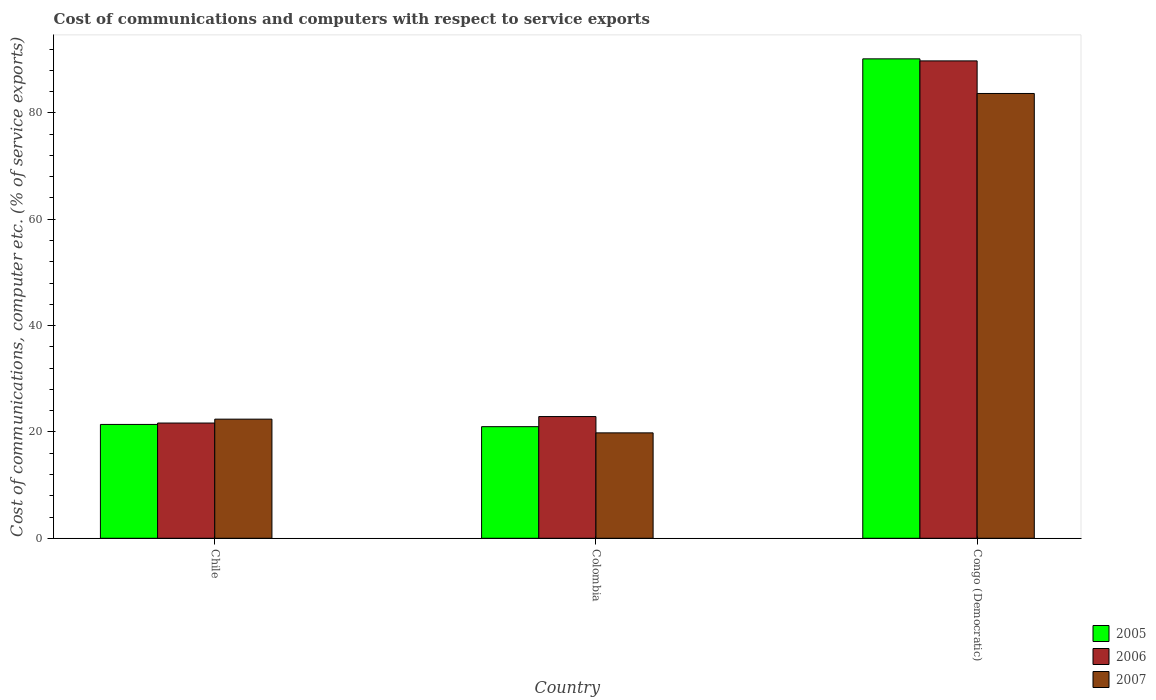Are the number of bars per tick equal to the number of legend labels?
Give a very brief answer. Yes. Are the number of bars on each tick of the X-axis equal?
Make the answer very short. Yes. How many bars are there on the 3rd tick from the left?
Give a very brief answer. 3. How many bars are there on the 2nd tick from the right?
Ensure brevity in your answer.  3. What is the cost of communications and computers in 2006 in Chile?
Offer a terse response. 21.67. Across all countries, what is the maximum cost of communications and computers in 2005?
Offer a terse response. 90.15. Across all countries, what is the minimum cost of communications and computers in 2005?
Give a very brief answer. 20.99. In which country was the cost of communications and computers in 2005 maximum?
Offer a very short reply. Congo (Democratic). In which country was the cost of communications and computers in 2007 minimum?
Your answer should be very brief. Colombia. What is the total cost of communications and computers in 2005 in the graph?
Your answer should be very brief. 132.55. What is the difference between the cost of communications and computers in 2006 in Chile and that in Congo (Democratic)?
Make the answer very short. -68.1. What is the difference between the cost of communications and computers in 2006 in Chile and the cost of communications and computers in 2007 in Colombia?
Provide a succinct answer. 1.85. What is the average cost of communications and computers in 2007 per country?
Offer a very short reply. 41.95. What is the difference between the cost of communications and computers of/in 2006 and cost of communications and computers of/in 2005 in Colombia?
Keep it short and to the point. 1.9. In how many countries, is the cost of communications and computers in 2006 greater than 52 %?
Provide a short and direct response. 1. What is the ratio of the cost of communications and computers in 2005 in Chile to that in Congo (Democratic)?
Offer a terse response. 0.24. Is the difference between the cost of communications and computers in 2006 in Chile and Congo (Democratic) greater than the difference between the cost of communications and computers in 2005 in Chile and Congo (Democratic)?
Make the answer very short. Yes. What is the difference between the highest and the second highest cost of communications and computers in 2007?
Provide a succinct answer. -63.82. What is the difference between the highest and the lowest cost of communications and computers in 2007?
Your answer should be compact. 63.82. What does the 1st bar from the left in Congo (Democratic) represents?
Ensure brevity in your answer.  2005. Is it the case that in every country, the sum of the cost of communications and computers in 2007 and cost of communications and computers in 2006 is greater than the cost of communications and computers in 2005?
Your answer should be compact. Yes. How many bars are there?
Your answer should be compact. 9. How many countries are there in the graph?
Your response must be concise. 3. Does the graph contain grids?
Keep it short and to the point. No. Where does the legend appear in the graph?
Provide a short and direct response. Bottom right. How are the legend labels stacked?
Ensure brevity in your answer.  Vertical. What is the title of the graph?
Give a very brief answer. Cost of communications and computers with respect to service exports. Does "1980" appear as one of the legend labels in the graph?
Your response must be concise. No. What is the label or title of the X-axis?
Offer a very short reply. Country. What is the label or title of the Y-axis?
Your response must be concise. Cost of communications, computer etc. (% of service exports). What is the Cost of communications, computer etc. (% of service exports) in 2005 in Chile?
Your answer should be very brief. 21.41. What is the Cost of communications, computer etc. (% of service exports) in 2006 in Chile?
Make the answer very short. 21.67. What is the Cost of communications, computer etc. (% of service exports) of 2007 in Chile?
Make the answer very short. 22.4. What is the Cost of communications, computer etc. (% of service exports) of 2005 in Colombia?
Your answer should be compact. 20.99. What is the Cost of communications, computer etc. (% of service exports) in 2006 in Colombia?
Give a very brief answer. 22.89. What is the Cost of communications, computer etc. (% of service exports) of 2007 in Colombia?
Ensure brevity in your answer.  19.82. What is the Cost of communications, computer etc. (% of service exports) of 2005 in Congo (Democratic)?
Ensure brevity in your answer.  90.15. What is the Cost of communications, computer etc. (% of service exports) in 2006 in Congo (Democratic)?
Your answer should be very brief. 89.77. What is the Cost of communications, computer etc. (% of service exports) of 2007 in Congo (Democratic)?
Provide a short and direct response. 83.64. Across all countries, what is the maximum Cost of communications, computer etc. (% of service exports) in 2005?
Provide a short and direct response. 90.15. Across all countries, what is the maximum Cost of communications, computer etc. (% of service exports) in 2006?
Provide a succinct answer. 89.77. Across all countries, what is the maximum Cost of communications, computer etc. (% of service exports) in 2007?
Offer a very short reply. 83.64. Across all countries, what is the minimum Cost of communications, computer etc. (% of service exports) in 2005?
Give a very brief answer. 20.99. Across all countries, what is the minimum Cost of communications, computer etc. (% of service exports) of 2006?
Provide a succinct answer. 21.67. Across all countries, what is the minimum Cost of communications, computer etc. (% of service exports) in 2007?
Ensure brevity in your answer.  19.82. What is the total Cost of communications, computer etc. (% of service exports) in 2005 in the graph?
Offer a very short reply. 132.55. What is the total Cost of communications, computer etc. (% of service exports) in 2006 in the graph?
Keep it short and to the point. 134.33. What is the total Cost of communications, computer etc. (% of service exports) of 2007 in the graph?
Your answer should be compact. 125.86. What is the difference between the Cost of communications, computer etc. (% of service exports) in 2005 in Chile and that in Colombia?
Offer a terse response. 0.42. What is the difference between the Cost of communications, computer etc. (% of service exports) of 2006 in Chile and that in Colombia?
Keep it short and to the point. -1.22. What is the difference between the Cost of communications, computer etc. (% of service exports) in 2007 in Chile and that in Colombia?
Keep it short and to the point. 2.58. What is the difference between the Cost of communications, computer etc. (% of service exports) of 2005 in Chile and that in Congo (Democratic)?
Your answer should be very brief. -68.74. What is the difference between the Cost of communications, computer etc. (% of service exports) in 2006 in Chile and that in Congo (Democratic)?
Your answer should be compact. -68.1. What is the difference between the Cost of communications, computer etc. (% of service exports) of 2007 in Chile and that in Congo (Democratic)?
Offer a terse response. -61.24. What is the difference between the Cost of communications, computer etc. (% of service exports) of 2005 in Colombia and that in Congo (Democratic)?
Provide a short and direct response. -69.16. What is the difference between the Cost of communications, computer etc. (% of service exports) in 2006 in Colombia and that in Congo (Democratic)?
Your answer should be compact. -66.88. What is the difference between the Cost of communications, computer etc. (% of service exports) of 2007 in Colombia and that in Congo (Democratic)?
Give a very brief answer. -63.82. What is the difference between the Cost of communications, computer etc. (% of service exports) of 2005 in Chile and the Cost of communications, computer etc. (% of service exports) of 2006 in Colombia?
Offer a very short reply. -1.48. What is the difference between the Cost of communications, computer etc. (% of service exports) in 2005 in Chile and the Cost of communications, computer etc. (% of service exports) in 2007 in Colombia?
Keep it short and to the point. 1.59. What is the difference between the Cost of communications, computer etc. (% of service exports) in 2006 in Chile and the Cost of communications, computer etc. (% of service exports) in 2007 in Colombia?
Your answer should be very brief. 1.85. What is the difference between the Cost of communications, computer etc. (% of service exports) of 2005 in Chile and the Cost of communications, computer etc. (% of service exports) of 2006 in Congo (Democratic)?
Give a very brief answer. -68.36. What is the difference between the Cost of communications, computer etc. (% of service exports) in 2005 in Chile and the Cost of communications, computer etc. (% of service exports) in 2007 in Congo (Democratic)?
Your answer should be very brief. -62.23. What is the difference between the Cost of communications, computer etc. (% of service exports) in 2006 in Chile and the Cost of communications, computer etc. (% of service exports) in 2007 in Congo (Democratic)?
Your response must be concise. -61.97. What is the difference between the Cost of communications, computer etc. (% of service exports) in 2005 in Colombia and the Cost of communications, computer etc. (% of service exports) in 2006 in Congo (Democratic)?
Offer a terse response. -68.78. What is the difference between the Cost of communications, computer etc. (% of service exports) in 2005 in Colombia and the Cost of communications, computer etc. (% of service exports) in 2007 in Congo (Democratic)?
Give a very brief answer. -62.65. What is the difference between the Cost of communications, computer etc. (% of service exports) in 2006 in Colombia and the Cost of communications, computer etc. (% of service exports) in 2007 in Congo (Democratic)?
Make the answer very short. -60.75. What is the average Cost of communications, computer etc. (% of service exports) of 2005 per country?
Ensure brevity in your answer.  44.18. What is the average Cost of communications, computer etc. (% of service exports) in 2006 per country?
Provide a succinct answer. 44.78. What is the average Cost of communications, computer etc. (% of service exports) in 2007 per country?
Offer a very short reply. 41.95. What is the difference between the Cost of communications, computer etc. (% of service exports) in 2005 and Cost of communications, computer etc. (% of service exports) in 2006 in Chile?
Keep it short and to the point. -0.26. What is the difference between the Cost of communications, computer etc. (% of service exports) in 2005 and Cost of communications, computer etc. (% of service exports) in 2007 in Chile?
Provide a succinct answer. -0.99. What is the difference between the Cost of communications, computer etc. (% of service exports) in 2006 and Cost of communications, computer etc. (% of service exports) in 2007 in Chile?
Provide a short and direct response. -0.73. What is the difference between the Cost of communications, computer etc. (% of service exports) in 2005 and Cost of communications, computer etc. (% of service exports) in 2006 in Colombia?
Provide a succinct answer. -1.9. What is the difference between the Cost of communications, computer etc. (% of service exports) of 2005 and Cost of communications, computer etc. (% of service exports) of 2007 in Colombia?
Your answer should be very brief. 1.17. What is the difference between the Cost of communications, computer etc. (% of service exports) in 2006 and Cost of communications, computer etc. (% of service exports) in 2007 in Colombia?
Offer a terse response. 3.07. What is the difference between the Cost of communications, computer etc. (% of service exports) of 2005 and Cost of communications, computer etc. (% of service exports) of 2006 in Congo (Democratic)?
Provide a succinct answer. 0.38. What is the difference between the Cost of communications, computer etc. (% of service exports) of 2005 and Cost of communications, computer etc. (% of service exports) of 2007 in Congo (Democratic)?
Give a very brief answer. 6.51. What is the difference between the Cost of communications, computer etc. (% of service exports) in 2006 and Cost of communications, computer etc. (% of service exports) in 2007 in Congo (Democratic)?
Make the answer very short. 6.13. What is the ratio of the Cost of communications, computer etc. (% of service exports) of 2005 in Chile to that in Colombia?
Provide a succinct answer. 1.02. What is the ratio of the Cost of communications, computer etc. (% of service exports) of 2006 in Chile to that in Colombia?
Ensure brevity in your answer.  0.95. What is the ratio of the Cost of communications, computer etc. (% of service exports) in 2007 in Chile to that in Colombia?
Ensure brevity in your answer.  1.13. What is the ratio of the Cost of communications, computer etc. (% of service exports) of 2005 in Chile to that in Congo (Democratic)?
Ensure brevity in your answer.  0.24. What is the ratio of the Cost of communications, computer etc. (% of service exports) of 2006 in Chile to that in Congo (Democratic)?
Offer a very short reply. 0.24. What is the ratio of the Cost of communications, computer etc. (% of service exports) in 2007 in Chile to that in Congo (Democratic)?
Your response must be concise. 0.27. What is the ratio of the Cost of communications, computer etc. (% of service exports) in 2005 in Colombia to that in Congo (Democratic)?
Provide a short and direct response. 0.23. What is the ratio of the Cost of communications, computer etc. (% of service exports) in 2006 in Colombia to that in Congo (Democratic)?
Ensure brevity in your answer.  0.26. What is the ratio of the Cost of communications, computer etc. (% of service exports) of 2007 in Colombia to that in Congo (Democratic)?
Your response must be concise. 0.24. What is the difference between the highest and the second highest Cost of communications, computer etc. (% of service exports) in 2005?
Provide a short and direct response. 68.74. What is the difference between the highest and the second highest Cost of communications, computer etc. (% of service exports) in 2006?
Offer a terse response. 66.88. What is the difference between the highest and the second highest Cost of communications, computer etc. (% of service exports) in 2007?
Give a very brief answer. 61.24. What is the difference between the highest and the lowest Cost of communications, computer etc. (% of service exports) in 2005?
Your answer should be very brief. 69.16. What is the difference between the highest and the lowest Cost of communications, computer etc. (% of service exports) of 2006?
Your answer should be compact. 68.1. What is the difference between the highest and the lowest Cost of communications, computer etc. (% of service exports) of 2007?
Give a very brief answer. 63.82. 